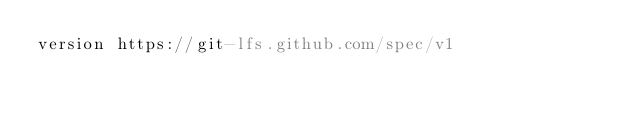<code> <loc_0><loc_0><loc_500><loc_500><_YAML_>version https://git-lfs.github.com/spec/v1</code> 